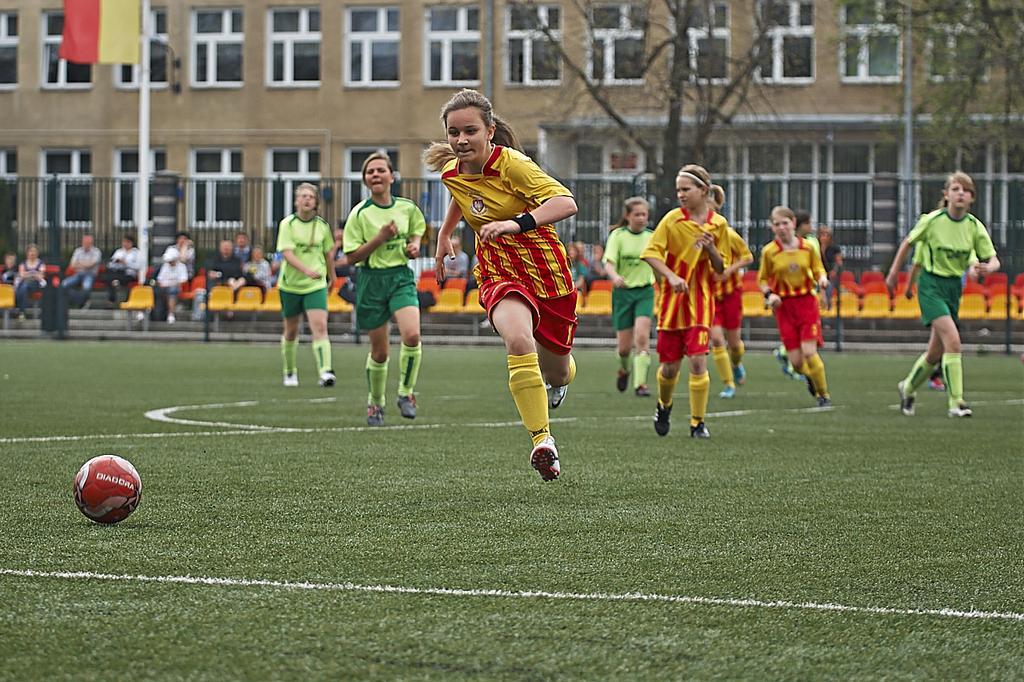Describe this image in one or two sentences. In this picture I can see few persons are playing the football in the middle. In the background few persons are sitting on the chairs and watching this game, there is an iron grill. At the top I can see few trees and buildings, there is a ball on the left side. 